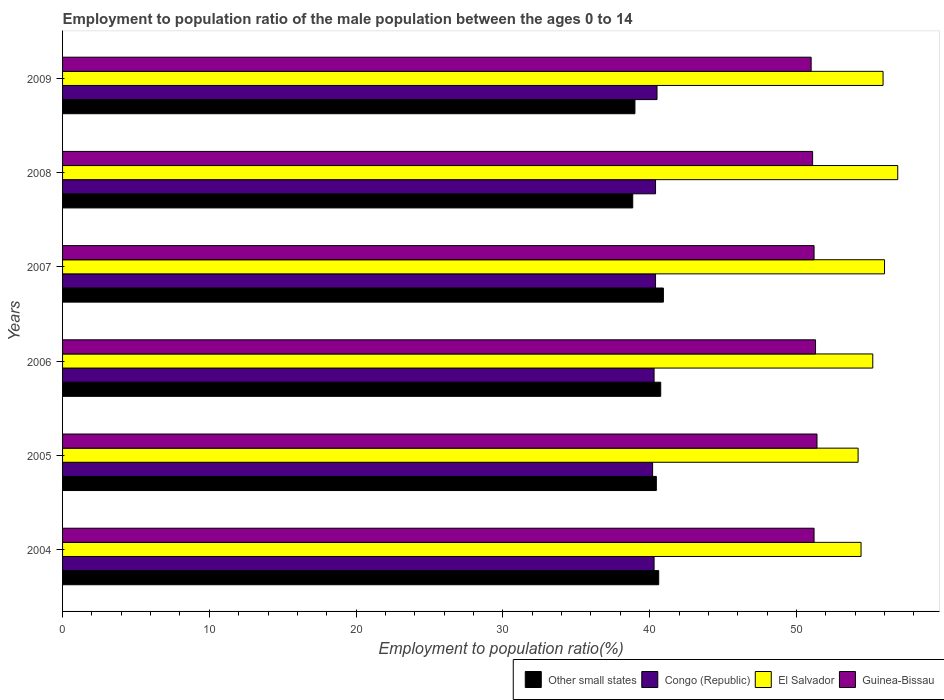How many different coloured bars are there?
Your answer should be compact. 4. Are the number of bars on each tick of the Y-axis equal?
Your answer should be very brief. Yes. How many bars are there on the 6th tick from the top?
Offer a very short reply. 4. In how many cases, is the number of bars for a given year not equal to the number of legend labels?
Offer a very short reply. 0. What is the employment to population ratio in El Salvador in 2006?
Keep it short and to the point. 55.2. Across all years, what is the maximum employment to population ratio in Other small states?
Offer a very short reply. 40.93. Across all years, what is the minimum employment to population ratio in El Salvador?
Your answer should be compact. 54.2. In which year was the employment to population ratio in El Salvador maximum?
Provide a short and direct response. 2008. What is the total employment to population ratio in Guinea-Bissau in the graph?
Provide a short and direct response. 307.2. What is the difference between the employment to population ratio in Guinea-Bissau in 2006 and that in 2008?
Your answer should be compact. 0.2. What is the average employment to population ratio in Guinea-Bissau per year?
Offer a very short reply. 51.2. In the year 2005, what is the difference between the employment to population ratio in Guinea-Bissau and employment to population ratio in Congo (Republic)?
Offer a terse response. 11.2. In how many years, is the employment to population ratio in Other small states greater than 40 %?
Ensure brevity in your answer.  4. What is the ratio of the employment to population ratio in El Salvador in 2005 to that in 2008?
Give a very brief answer. 0.95. Is the employment to population ratio in El Salvador in 2004 less than that in 2008?
Your response must be concise. Yes. What is the difference between the highest and the second highest employment to population ratio in Guinea-Bissau?
Your answer should be very brief. 0.1. What is the difference between the highest and the lowest employment to population ratio in Other small states?
Keep it short and to the point. 2.09. What does the 1st bar from the top in 2007 represents?
Provide a succinct answer. Guinea-Bissau. What does the 4th bar from the bottom in 2009 represents?
Provide a succinct answer. Guinea-Bissau. Are all the bars in the graph horizontal?
Your answer should be very brief. Yes. How many years are there in the graph?
Offer a terse response. 6. Does the graph contain any zero values?
Your response must be concise. No. Does the graph contain grids?
Ensure brevity in your answer.  No. Where does the legend appear in the graph?
Offer a very short reply. Bottom right. How many legend labels are there?
Keep it short and to the point. 4. How are the legend labels stacked?
Provide a short and direct response. Horizontal. What is the title of the graph?
Offer a very short reply. Employment to population ratio of the male population between the ages 0 to 14. What is the Employment to population ratio(%) in Other small states in 2004?
Ensure brevity in your answer.  40.61. What is the Employment to population ratio(%) of Congo (Republic) in 2004?
Give a very brief answer. 40.3. What is the Employment to population ratio(%) of El Salvador in 2004?
Give a very brief answer. 54.4. What is the Employment to population ratio(%) of Guinea-Bissau in 2004?
Your answer should be very brief. 51.2. What is the Employment to population ratio(%) in Other small states in 2005?
Offer a very short reply. 40.45. What is the Employment to population ratio(%) of Congo (Republic) in 2005?
Offer a very short reply. 40.2. What is the Employment to population ratio(%) of El Salvador in 2005?
Make the answer very short. 54.2. What is the Employment to population ratio(%) of Guinea-Bissau in 2005?
Offer a very short reply. 51.4. What is the Employment to population ratio(%) of Other small states in 2006?
Make the answer very short. 40.75. What is the Employment to population ratio(%) of Congo (Republic) in 2006?
Give a very brief answer. 40.3. What is the Employment to population ratio(%) in El Salvador in 2006?
Your answer should be compact. 55.2. What is the Employment to population ratio(%) in Guinea-Bissau in 2006?
Provide a succinct answer. 51.3. What is the Employment to population ratio(%) in Other small states in 2007?
Keep it short and to the point. 40.93. What is the Employment to population ratio(%) of Congo (Republic) in 2007?
Offer a terse response. 40.4. What is the Employment to population ratio(%) of Guinea-Bissau in 2007?
Offer a terse response. 51.2. What is the Employment to population ratio(%) of Other small states in 2008?
Offer a very short reply. 38.85. What is the Employment to population ratio(%) in Congo (Republic) in 2008?
Keep it short and to the point. 40.4. What is the Employment to population ratio(%) in El Salvador in 2008?
Your answer should be very brief. 56.9. What is the Employment to population ratio(%) in Guinea-Bissau in 2008?
Provide a short and direct response. 51.1. What is the Employment to population ratio(%) in Other small states in 2009?
Offer a terse response. 39. What is the Employment to population ratio(%) in Congo (Republic) in 2009?
Your answer should be compact. 40.5. What is the Employment to population ratio(%) of El Salvador in 2009?
Your answer should be compact. 55.9. Across all years, what is the maximum Employment to population ratio(%) of Other small states?
Your answer should be compact. 40.93. Across all years, what is the maximum Employment to population ratio(%) of Congo (Republic)?
Offer a terse response. 40.5. Across all years, what is the maximum Employment to population ratio(%) in El Salvador?
Give a very brief answer. 56.9. Across all years, what is the maximum Employment to population ratio(%) in Guinea-Bissau?
Make the answer very short. 51.4. Across all years, what is the minimum Employment to population ratio(%) in Other small states?
Your response must be concise. 38.85. Across all years, what is the minimum Employment to population ratio(%) of Congo (Republic)?
Give a very brief answer. 40.2. Across all years, what is the minimum Employment to population ratio(%) in El Salvador?
Your answer should be compact. 54.2. Across all years, what is the minimum Employment to population ratio(%) in Guinea-Bissau?
Keep it short and to the point. 51. What is the total Employment to population ratio(%) in Other small states in the graph?
Offer a very short reply. 240.6. What is the total Employment to population ratio(%) in Congo (Republic) in the graph?
Ensure brevity in your answer.  242.1. What is the total Employment to population ratio(%) in El Salvador in the graph?
Your answer should be very brief. 332.6. What is the total Employment to population ratio(%) in Guinea-Bissau in the graph?
Make the answer very short. 307.2. What is the difference between the Employment to population ratio(%) in Other small states in 2004 and that in 2005?
Your answer should be compact. 0.16. What is the difference between the Employment to population ratio(%) in Congo (Republic) in 2004 and that in 2005?
Make the answer very short. 0.1. What is the difference between the Employment to population ratio(%) of El Salvador in 2004 and that in 2005?
Provide a short and direct response. 0.2. What is the difference between the Employment to population ratio(%) of Guinea-Bissau in 2004 and that in 2005?
Your answer should be very brief. -0.2. What is the difference between the Employment to population ratio(%) in Other small states in 2004 and that in 2006?
Offer a terse response. -0.14. What is the difference between the Employment to population ratio(%) in Congo (Republic) in 2004 and that in 2006?
Your answer should be compact. 0. What is the difference between the Employment to population ratio(%) of El Salvador in 2004 and that in 2006?
Make the answer very short. -0.8. What is the difference between the Employment to population ratio(%) of Guinea-Bissau in 2004 and that in 2006?
Ensure brevity in your answer.  -0.1. What is the difference between the Employment to population ratio(%) of Other small states in 2004 and that in 2007?
Your response must be concise. -0.32. What is the difference between the Employment to population ratio(%) of Congo (Republic) in 2004 and that in 2007?
Make the answer very short. -0.1. What is the difference between the Employment to population ratio(%) of Other small states in 2004 and that in 2008?
Your answer should be very brief. 1.77. What is the difference between the Employment to population ratio(%) of El Salvador in 2004 and that in 2008?
Keep it short and to the point. -2.5. What is the difference between the Employment to population ratio(%) in Other small states in 2004 and that in 2009?
Offer a terse response. 1.62. What is the difference between the Employment to population ratio(%) in El Salvador in 2004 and that in 2009?
Your answer should be very brief. -1.5. What is the difference between the Employment to population ratio(%) in Other small states in 2005 and that in 2006?
Give a very brief answer. -0.3. What is the difference between the Employment to population ratio(%) of El Salvador in 2005 and that in 2006?
Your answer should be compact. -1. What is the difference between the Employment to population ratio(%) of Other small states in 2005 and that in 2007?
Provide a succinct answer. -0.48. What is the difference between the Employment to population ratio(%) of Congo (Republic) in 2005 and that in 2007?
Make the answer very short. -0.2. What is the difference between the Employment to population ratio(%) of El Salvador in 2005 and that in 2007?
Give a very brief answer. -1.8. What is the difference between the Employment to population ratio(%) in Guinea-Bissau in 2005 and that in 2007?
Offer a terse response. 0.2. What is the difference between the Employment to population ratio(%) of Other small states in 2005 and that in 2008?
Your response must be concise. 1.61. What is the difference between the Employment to population ratio(%) of Guinea-Bissau in 2005 and that in 2008?
Your answer should be compact. 0.3. What is the difference between the Employment to population ratio(%) in Other small states in 2005 and that in 2009?
Make the answer very short. 1.46. What is the difference between the Employment to population ratio(%) of Congo (Republic) in 2005 and that in 2009?
Your answer should be very brief. -0.3. What is the difference between the Employment to population ratio(%) of Guinea-Bissau in 2005 and that in 2009?
Offer a very short reply. 0.4. What is the difference between the Employment to population ratio(%) in Other small states in 2006 and that in 2007?
Provide a succinct answer. -0.18. What is the difference between the Employment to population ratio(%) in El Salvador in 2006 and that in 2007?
Provide a short and direct response. -0.8. What is the difference between the Employment to population ratio(%) of Guinea-Bissau in 2006 and that in 2007?
Your answer should be very brief. 0.1. What is the difference between the Employment to population ratio(%) of Other small states in 2006 and that in 2008?
Offer a very short reply. 1.91. What is the difference between the Employment to population ratio(%) of Congo (Republic) in 2006 and that in 2008?
Ensure brevity in your answer.  -0.1. What is the difference between the Employment to population ratio(%) in El Salvador in 2006 and that in 2008?
Your answer should be compact. -1.7. What is the difference between the Employment to population ratio(%) of Other small states in 2006 and that in 2009?
Your answer should be very brief. 1.76. What is the difference between the Employment to population ratio(%) in El Salvador in 2006 and that in 2009?
Offer a terse response. -0.7. What is the difference between the Employment to population ratio(%) in Guinea-Bissau in 2006 and that in 2009?
Make the answer very short. 0.3. What is the difference between the Employment to population ratio(%) of Other small states in 2007 and that in 2008?
Keep it short and to the point. 2.09. What is the difference between the Employment to population ratio(%) in Congo (Republic) in 2007 and that in 2008?
Make the answer very short. 0. What is the difference between the Employment to population ratio(%) of El Salvador in 2007 and that in 2008?
Offer a very short reply. -0.9. What is the difference between the Employment to population ratio(%) in Other small states in 2007 and that in 2009?
Make the answer very short. 1.94. What is the difference between the Employment to population ratio(%) in Congo (Republic) in 2007 and that in 2009?
Offer a very short reply. -0.1. What is the difference between the Employment to population ratio(%) of El Salvador in 2007 and that in 2009?
Your response must be concise. 0.1. What is the difference between the Employment to population ratio(%) in Guinea-Bissau in 2007 and that in 2009?
Offer a very short reply. 0.2. What is the difference between the Employment to population ratio(%) in Other small states in 2008 and that in 2009?
Keep it short and to the point. -0.15. What is the difference between the Employment to population ratio(%) in Other small states in 2004 and the Employment to population ratio(%) in Congo (Republic) in 2005?
Provide a succinct answer. 0.41. What is the difference between the Employment to population ratio(%) of Other small states in 2004 and the Employment to population ratio(%) of El Salvador in 2005?
Your response must be concise. -13.59. What is the difference between the Employment to population ratio(%) of Other small states in 2004 and the Employment to population ratio(%) of Guinea-Bissau in 2005?
Your answer should be very brief. -10.79. What is the difference between the Employment to population ratio(%) of Congo (Republic) in 2004 and the Employment to population ratio(%) of El Salvador in 2005?
Provide a short and direct response. -13.9. What is the difference between the Employment to population ratio(%) in Congo (Republic) in 2004 and the Employment to population ratio(%) in Guinea-Bissau in 2005?
Your answer should be very brief. -11.1. What is the difference between the Employment to population ratio(%) in El Salvador in 2004 and the Employment to population ratio(%) in Guinea-Bissau in 2005?
Offer a very short reply. 3. What is the difference between the Employment to population ratio(%) of Other small states in 2004 and the Employment to population ratio(%) of Congo (Republic) in 2006?
Keep it short and to the point. 0.31. What is the difference between the Employment to population ratio(%) in Other small states in 2004 and the Employment to population ratio(%) in El Salvador in 2006?
Offer a terse response. -14.59. What is the difference between the Employment to population ratio(%) of Other small states in 2004 and the Employment to population ratio(%) of Guinea-Bissau in 2006?
Provide a succinct answer. -10.69. What is the difference between the Employment to population ratio(%) of Congo (Republic) in 2004 and the Employment to population ratio(%) of El Salvador in 2006?
Give a very brief answer. -14.9. What is the difference between the Employment to population ratio(%) in Congo (Republic) in 2004 and the Employment to population ratio(%) in Guinea-Bissau in 2006?
Make the answer very short. -11. What is the difference between the Employment to population ratio(%) in Other small states in 2004 and the Employment to population ratio(%) in Congo (Republic) in 2007?
Your response must be concise. 0.21. What is the difference between the Employment to population ratio(%) in Other small states in 2004 and the Employment to population ratio(%) in El Salvador in 2007?
Make the answer very short. -15.39. What is the difference between the Employment to population ratio(%) of Other small states in 2004 and the Employment to population ratio(%) of Guinea-Bissau in 2007?
Give a very brief answer. -10.59. What is the difference between the Employment to population ratio(%) in Congo (Republic) in 2004 and the Employment to population ratio(%) in El Salvador in 2007?
Offer a very short reply. -15.7. What is the difference between the Employment to population ratio(%) in Other small states in 2004 and the Employment to population ratio(%) in Congo (Republic) in 2008?
Your response must be concise. 0.21. What is the difference between the Employment to population ratio(%) in Other small states in 2004 and the Employment to population ratio(%) in El Salvador in 2008?
Keep it short and to the point. -16.29. What is the difference between the Employment to population ratio(%) in Other small states in 2004 and the Employment to population ratio(%) in Guinea-Bissau in 2008?
Offer a very short reply. -10.49. What is the difference between the Employment to population ratio(%) of Congo (Republic) in 2004 and the Employment to population ratio(%) of El Salvador in 2008?
Make the answer very short. -16.6. What is the difference between the Employment to population ratio(%) in Congo (Republic) in 2004 and the Employment to population ratio(%) in Guinea-Bissau in 2008?
Keep it short and to the point. -10.8. What is the difference between the Employment to population ratio(%) in El Salvador in 2004 and the Employment to population ratio(%) in Guinea-Bissau in 2008?
Keep it short and to the point. 3.3. What is the difference between the Employment to population ratio(%) of Other small states in 2004 and the Employment to population ratio(%) of Congo (Republic) in 2009?
Offer a terse response. 0.11. What is the difference between the Employment to population ratio(%) in Other small states in 2004 and the Employment to population ratio(%) in El Salvador in 2009?
Offer a very short reply. -15.29. What is the difference between the Employment to population ratio(%) of Other small states in 2004 and the Employment to population ratio(%) of Guinea-Bissau in 2009?
Provide a succinct answer. -10.39. What is the difference between the Employment to population ratio(%) of Congo (Republic) in 2004 and the Employment to population ratio(%) of El Salvador in 2009?
Provide a succinct answer. -15.6. What is the difference between the Employment to population ratio(%) of El Salvador in 2004 and the Employment to population ratio(%) of Guinea-Bissau in 2009?
Provide a short and direct response. 3.4. What is the difference between the Employment to population ratio(%) in Other small states in 2005 and the Employment to population ratio(%) in Congo (Republic) in 2006?
Your response must be concise. 0.15. What is the difference between the Employment to population ratio(%) of Other small states in 2005 and the Employment to population ratio(%) of El Salvador in 2006?
Make the answer very short. -14.75. What is the difference between the Employment to population ratio(%) in Other small states in 2005 and the Employment to population ratio(%) in Guinea-Bissau in 2006?
Your answer should be compact. -10.85. What is the difference between the Employment to population ratio(%) of Congo (Republic) in 2005 and the Employment to population ratio(%) of El Salvador in 2006?
Your response must be concise. -15. What is the difference between the Employment to population ratio(%) in Other small states in 2005 and the Employment to population ratio(%) in Congo (Republic) in 2007?
Your answer should be compact. 0.05. What is the difference between the Employment to population ratio(%) in Other small states in 2005 and the Employment to population ratio(%) in El Salvador in 2007?
Ensure brevity in your answer.  -15.55. What is the difference between the Employment to population ratio(%) in Other small states in 2005 and the Employment to population ratio(%) in Guinea-Bissau in 2007?
Your answer should be very brief. -10.75. What is the difference between the Employment to population ratio(%) of Congo (Republic) in 2005 and the Employment to population ratio(%) of El Salvador in 2007?
Ensure brevity in your answer.  -15.8. What is the difference between the Employment to population ratio(%) in Congo (Republic) in 2005 and the Employment to population ratio(%) in Guinea-Bissau in 2007?
Make the answer very short. -11. What is the difference between the Employment to population ratio(%) of El Salvador in 2005 and the Employment to population ratio(%) of Guinea-Bissau in 2007?
Give a very brief answer. 3. What is the difference between the Employment to population ratio(%) of Other small states in 2005 and the Employment to population ratio(%) of Congo (Republic) in 2008?
Offer a very short reply. 0.05. What is the difference between the Employment to population ratio(%) of Other small states in 2005 and the Employment to population ratio(%) of El Salvador in 2008?
Your response must be concise. -16.45. What is the difference between the Employment to population ratio(%) in Other small states in 2005 and the Employment to population ratio(%) in Guinea-Bissau in 2008?
Your answer should be very brief. -10.65. What is the difference between the Employment to population ratio(%) of Congo (Republic) in 2005 and the Employment to population ratio(%) of El Salvador in 2008?
Make the answer very short. -16.7. What is the difference between the Employment to population ratio(%) in Congo (Republic) in 2005 and the Employment to population ratio(%) in Guinea-Bissau in 2008?
Your response must be concise. -10.9. What is the difference between the Employment to population ratio(%) in El Salvador in 2005 and the Employment to population ratio(%) in Guinea-Bissau in 2008?
Offer a very short reply. 3.1. What is the difference between the Employment to population ratio(%) in Other small states in 2005 and the Employment to population ratio(%) in Congo (Republic) in 2009?
Provide a succinct answer. -0.05. What is the difference between the Employment to population ratio(%) in Other small states in 2005 and the Employment to population ratio(%) in El Salvador in 2009?
Ensure brevity in your answer.  -15.45. What is the difference between the Employment to population ratio(%) of Other small states in 2005 and the Employment to population ratio(%) of Guinea-Bissau in 2009?
Provide a succinct answer. -10.55. What is the difference between the Employment to population ratio(%) in Congo (Republic) in 2005 and the Employment to population ratio(%) in El Salvador in 2009?
Ensure brevity in your answer.  -15.7. What is the difference between the Employment to population ratio(%) of Congo (Republic) in 2005 and the Employment to population ratio(%) of Guinea-Bissau in 2009?
Offer a very short reply. -10.8. What is the difference between the Employment to population ratio(%) of El Salvador in 2005 and the Employment to population ratio(%) of Guinea-Bissau in 2009?
Your answer should be very brief. 3.2. What is the difference between the Employment to population ratio(%) in Other small states in 2006 and the Employment to population ratio(%) in Congo (Republic) in 2007?
Ensure brevity in your answer.  0.35. What is the difference between the Employment to population ratio(%) in Other small states in 2006 and the Employment to population ratio(%) in El Salvador in 2007?
Your response must be concise. -15.25. What is the difference between the Employment to population ratio(%) of Other small states in 2006 and the Employment to population ratio(%) of Guinea-Bissau in 2007?
Your answer should be compact. -10.45. What is the difference between the Employment to population ratio(%) in Congo (Republic) in 2006 and the Employment to population ratio(%) in El Salvador in 2007?
Make the answer very short. -15.7. What is the difference between the Employment to population ratio(%) in Congo (Republic) in 2006 and the Employment to population ratio(%) in Guinea-Bissau in 2007?
Keep it short and to the point. -10.9. What is the difference between the Employment to population ratio(%) in Other small states in 2006 and the Employment to population ratio(%) in Congo (Republic) in 2008?
Your answer should be compact. 0.35. What is the difference between the Employment to population ratio(%) of Other small states in 2006 and the Employment to population ratio(%) of El Salvador in 2008?
Your response must be concise. -16.15. What is the difference between the Employment to population ratio(%) of Other small states in 2006 and the Employment to population ratio(%) of Guinea-Bissau in 2008?
Keep it short and to the point. -10.35. What is the difference between the Employment to population ratio(%) in Congo (Republic) in 2006 and the Employment to population ratio(%) in El Salvador in 2008?
Your response must be concise. -16.6. What is the difference between the Employment to population ratio(%) in Congo (Republic) in 2006 and the Employment to population ratio(%) in Guinea-Bissau in 2008?
Your response must be concise. -10.8. What is the difference between the Employment to population ratio(%) in El Salvador in 2006 and the Employment to population ratio(%) in Guinea-Bissau in 2008?
Ensure brevity in your answer.  4.1. What is the difference between the Employment to population ratio(%) of Other small states in 2006 and the Employment to population ratio(%) of Congo (Republic) in 2009?
Provide a succinct answer. 0.25. What is the difference between the Employment to population ratio(%) of Other small states in 2006 and the Employment to population ratio(%) of El Salvador in 2009?
Give a very brief answer. -15.15. What is the difference between the Employment to population ratio(%) of Other small states in 2006 and the Employment to population ratio(%) of Guinea-Bissau in 2009?
Offer a very short reply. -10.25. What is the difference between the Employment to population ratio(%) of Congo (Republic) in 2006 and the Employment to population ratio(%) of El Salvador in 2009?
Your response must be concise. -15.6. What is the difference between the Employment to population ratio(%) of Other small states in 2007 and the Employment to population ratio(%) of Congo (Republic) in 2008?
Ensure brevity in your answer.  0.53. What is the difference between the Employment to population ratio(%) of Other small states in 2007 and the Employment to population ratio(%) of El Salvador in 2008?
Your answer should be compact. -15.97. What is the difference between the Employment to population ratio(%) of Other small states in 2007 and the Employment to population ratio(%) of Guinea-Bissau in 2008?
Offer a terse response. -10.17. What is the difference between the Employment to population ratio(%) of Congo (Republic) in 2007 and the Employment to population ratio(%) of El Salvador in 2008?
Your answer should be very brief. -16.5. What is the difference between the Employment to population ratio(%) in Other small states in 2007 and the Employment to population ratio(%) in Congo (Republic) in 2009?
Provide a succinct answer. 0.43. What is the difference between the Employment to population ratio(%) in Other small states in 2007 and the Employment to population ratio(%) in El Salvador in 2009?
Your answer should be compact. -14.97. What is the difference between the Employment to population ratio(%) of Other small states in 2007 and the Employment to population ratio(%) of Guinea-Bissau in 2009?
Provide a short and direct response. -10.07. What is the difference between the Employment to population ratio(%) of Congo (Republic) in 2007 and the Employment to population ratio(%) of El Salvador in 2009?
Your answer should be compact. -15.5. What is the difference between the Employment to population ratio(%) of El Salvador in 2007 and the Employment to population ratio(%) of Guinea-Bissau in 2009?
Offer a terse response. 5. What is the difference between the Employment to population ratio(%) in Other small states in 2008 and the Employment to population ratio(%) in Congo (Republic) in 2009?
Your answer should be compact. -1.65. What is the difference between the Employment to population ratio(%) of Other small states in 2008 and the Employment to population ratio(%) of El Salvador in 2009?
Your answer should be very brief. -17.05. What is the difference between the Employment to population ratio(%) in Other small states in 2008 and the Employment to population ratio(%) in Guinea-Bissau in 2009?
Keep it short and to the point. -12.15. What is the difference between the Employment to population ratio(%) of Congo (Republic) in 2008 and the Employment to population ratio(%) of El Salvador in 2009?
Give a very brief answer. -15.5. What is the difference between the Employment to population ratio(%) in Congo (Republic) in 2008 and the Employment to population ratio(%) in Guinea-Bissau in 2009?
Your response must be concise. -10.6. What is the average Employment to population ratio(%) in Other small states per year?
Your answer should be very brief. 40.1. What is the average Employment to population ratio(%) in Congo (Republic) per year?
Provide a short and direct response. 40.35. What is the average Employment to population ratio(%) in El Salvador per year?
Your answer should be compact. 55.43. What is the average Employment to population ratio(%) of Guinea-Bissau per year?
Your answer should be very brief. 51.2. In the year 2004, what is the difference between the Employment to population ratio(%) of Other small states and Employment to population ratio(%) of Congo (Republic)?
Provide a succinct answer. 0.31. In the year 2004, what is the difference between the Employment to population ratio(%) of Other small states and Employment to population ratio(%) of El Salvador?
Keep it short and to the point. -13.79. In the year 2004, what is the difference between the Employment to population ratio(%) of Other small states and Employment to population ratio(%) of Guinea-Bissau?
Provide a succinct answer. -10.59. In the year 2004, what is the difference between the Employment to population ratio(%) in Congo (Republic) and Employment to population ratio(%) in El Salvador?
Your response must be concise. -14.1. In the year 2004, what is the difference between the Employment to population ratio(%) of Congo (Republic) and Employment to population ratio(%) of Guinea-Bissau?
Make the answer very short. -10.9. In the year 2004, what is the difference between the Employment to population ratio(%) in El Salvador and Employment to population ratio(%) in Guinea-Bissau?
Offer a terse response. 3.2. In the year 2005, what is the difference between the Employment to population ratio(%) of Other small states and Employment to population ratio(%) of Congo (Republic)?
Make the answer very short. 0.25. In the year 2005, what is the difference between the Employment to population ratio(%) of Other small states and Employment to population ratio(%) of El Salvador?
Your answer should be compact. -13.75. In the year 2005, what is the difference between the Employment to population ratio(%) of Other small states and Employment to population ratio(%) of Guinea-Bissau?
Your response must be concise. -10.95. In the year 2005, what is the difference between the Employment to population ratio(%) in Congo (Republic) and Employment to population ratio(%) in El Salvador?
Offer a very short reply. -14. In the year 2005, what is the difference between the Employment to population ratio(%) in Congo (Republic) and Employment to population ratio(%) in Guinea-Bissau?
Offer a very short reply. -11.2. In the year 2006, what is the difference between the Employment to population ratio(%) of Other small states and Employment to population ratio(%) of Congo (Republic)?
Provide a short and direct response. 0.45. In the year 2006, what is the difference between the Employment to population ratio(%) of Other small states and Employment to population ratio(%) of El Salvador?
Your answer should be very brief. -14.45. In the year 2006, what is the difference between the Employment to population ratio(%) in Other small states and Employment to population ratio(%) in Guinea-Bissau?
Keep it short and to the point. -10.55. In the year 2006, what is the difference between the Employment to population ratio(%) of Congo (Republic) and Employment to population ratio(%) of El Salvador?
Your answer should be very brief. -14.9. In the year 2007, what is the difference between the Employment to population ratio(%) of Other small states and Employment to population ratio(%) of Congo (Republic)?
Give a very brief answer. 0.53. In the year 2007, what is the difference between the Employment to population ratio(%) in Other small states and Employment to population ratio(%) in El Salvador?
Provide a short and direct response. -15.07. In the year 2007, what is the difference between the Employment to population ratio(%) in Other small states and Employment to population ratio(%) in Guinea-Bissau?
Ensure brevity in your answer.  -10.27. In the year 2007, what is the difference between the Employment to population ratio(%) in Congo (Republic) and Employment to population ratio(%) in El Salvador?
Keep it short and to the point. -15.6. In the year 2007, what is the difference between the Employment to population ratio(%) in Congo (Republic) and Employment to population ratio(%) in Guinea-Bissau?
Ensure brevity in your answer.  -10.8. In the year 2008, what is the difference between the Employment to population ratio(%) of Other small states and Employment to population ratio(%) of Congo (Republic)?
Provide a succinct answer. -1.55. In the year 2008, what is the difference between the Employment to population ratio(%) of Other small states and Employment to population ratio(%) of El Salvador?
Your answer should be compact. -18.05. In the year 2008, what is the difference between the Employment to population ratio(%) in Other small states and Employment to population ratio(%) in Guinea-Bissau?
Keep it short and to the point. -12.25. In the year 2008, what is the difference between the Employment to population ratio(%) in Congo (Republic) and Employment to population ratio(%) in El Salvador?
Give a very brief answer. -16.5. In the year 2008, what is the difference between the Employment to population ratio(%) of El Salvador and Employment to population ratio(%) of Guinea-Bissau?
Your answer should be compact. 5.8. In the year 2009, what is the difference between the Employment to population ratio(%) of Other small states and Employment to population ratio(%) of Congo (Republic)?
Give a very brief answer. -1.5. In the year 2009, what is the difference between the Employment to population ratio(%) of Other small states and Employment to population ratio(%) of El Salvador?
Keep it short and to the point. -16.9. In the year 2009, what is the difference between the Employment to population ratio(%) of Other small states and Employment to population ratio(%) of Guinea-Bissau?
Your response must be concise. -12. In the year 2009, what is the difference between the Employment to population ratio(%) in Congo (Republic) and Employment to population ratio(%) in El Salvador?
Make the answer very short. -15.4. What is the ratio of the Employment to population ratio(%) in Other small states in 2004 to that in 2005?
Your answer should be compact. 1. What is the ratio of the Employment to population ratio(%) of Congo (Republic) in 2004 to that in 2005?
Your response must be concise. 1. What is the ratio of the Employment to population ratio(%) of El Salvador in 2004 to that in 2005?
Provide a short and direct response. 1. What is the ratio of the Employment to population ratio(%) of Guinea-Bissau in 2004 to that in 2005?
Provide a short and direct response. 1. What is the ratio of the Employment to population ratio(%) of Congo (Republic) in 2004 to that in 2006?
Make the answer very short. 1. What is the ratio of the Employment to population ratio(%) in El Salvador in 2004 to that in 2006?
Offer a very short reply. 0.99. What is the ratio of the Employment to population ratio(%) of El Salvador in 2004 to that in 2007?
Offer a very short reply. 0.97. What is the ratio of the Employment to population ratio(%) of Other small states in 2004 to that in 2008?
Offer a terse response. 1.05. What is the ratio of the Employment to population ratio(%) in El Salvador in 2004 to that in 2008?
Give a very brief answer. 0.96. What is the ratio of the Employment to population ratio(%) in Other small states in 2004 to that in 2009?
Provide a short and direct response. 1.04. What is the ratio of the Employment to population ratio(%) in Congo (Republic) in 2004 to that in 2009?
Ensure brevity in your answer.  1. What is the ratio of the Employment to population ratio(%) of El Salvador in 2004 to that in 2009?
Provide a short and direct response. 0.97. What is the ratio of the Employment to population ratio(%) of Guinea-Bissau in 2004 to that in 2009?
Give a very brief answer. 1. What is the ratio of the Employment to population ratio(%) in Congo (Republic) in 2005 to that in 2006?
Offer a terse response. 1. What is the ratio of the Employment to population ratio(%) in El Salvador in 2005 to that in 2006?
Your answer should be very brief. 0.98. What is the ratio of the Employment to population ratio(%) in Other small states in 2005 to that in 2007?
Provide a succinct answer. 0.99. What is the ratio of the Employment to population ratio(%) of Congo (Republic) in 2005 to that in 2007?
Give a very brief answer. 0.99. What is the ratio of the Employment to population ratio(%) in El Salvador in 2005 to that in 2007?
Your response must be concise. 0.97. What is the ratio of the Employment to population ratio(%) in Other small states in 2005 to that in 2008?
Ensure brevity in your answer.  1.04. What is the ratio of the Employment to population ratio(%) in El Salvador in 2005 to that in 2008?
Provide a short and direct response. 0.95. What is the ratio of the Employment to population ratio(%) of Guinea-Bissau in 2005 to that in 2008?
Offer a very short reply. 1.01. What is the ratio of the Employment to population ratio(%) in Other small states in 2005 to that in 2009?
Provide a short and direct response. 1.04. What is the ratio of the Employment to population ratio(%) of Congo (Republic) in 2005 to that in 2009?
Your response must be concise. 0.99. What is the ratio of the Employment to population ratio(%) of El Salvador in 2005 to that in 2009?
Your response must be concise. 0.97. What is the ratio of the Employment to population ratio(%) of Guinea-Bissau in 2005 to that in 2009?
Provide a succinct answer. 1.01. What is the ratio of the Employment to population ratio(%) in Other small states in 2006 to that in 2007?
Keep it short and to the point. 1. What is the ratio of the Employment to population ratio(%) in Congo (Republic) in 2006 to that in 2007?
Keep it short and to the point. 1. What is the ratio of the Employment to population ratio(%) in El Salvador in 2006 to that in 2007?
Provide a succinct answer. 0.99. What is the ratio of the Employment to population ratio(%) in Other small states in 2006 to that in 2008?
Keep it short and to the point. 1.05. What is the ratio of the Employment to population ratio(%) of El Salvador in 2006 to that in 2008?
Give a very brief answer. 0.97. What is the ratio of the Employment to population ratio(%) of Other small states in 2006 to that in 2009?
Your answer should be very brief. 1.05. What is the ratio of the Employment to population ratio(%) of El Salvador in 2006 to that in 2009?
Make the answer very short. 0.99. What is the ratio of the Employment to population ratio(%) of Guinea-Bissau in 2006 to that in 2009?
Your response must be concise. 1.01. What is the ratio of the Employment to population ratio(%) in Other small states in 2007 to that in 2008?
Your answer should be compact. 1.05. What is the ratio of the Employment to population ratio(%) of El Salvador in 2007 to that in 2008?
Your answer should be compact. 0.98. What is the ratio of the Employment to population ratio(%) in Guinea-Bissau in 2007 to that in 2008?
Offer a very short reply. 1. What is the ratio of the Employment to population ratio(%) of Other small states in 2007 to that in 2009?
Your answer should be very brief. 1.05. What is the ratio of the Employment to population ratio(%) in El Salvador in 2007 to that in 2009?
Give a very brief answer. 1. What is the ratio of the Employment to population ratio(%) in Guinea-Bissau in 2007 to that in 2009?
Give a very brief answer. 1. What is the ratio of the Employment to population ratio(%) of Congo (Republic) in 2008 to that in 2009?
Keep it short and to the point. 1. What is the ratio of the Employment to population ratio(%) in El Salvador in 2008 to that in 2009?
Offer a very short reply. 1.02. What is the difference between the highest and the second highest Employment to population ratio(%) of Other small states?
Provide a succinct answer. 0.18. What is the difference between the highest and the lowest Employment to population ratio(%) in Other small states?
Ensure brevity in your answer.  2.09. 